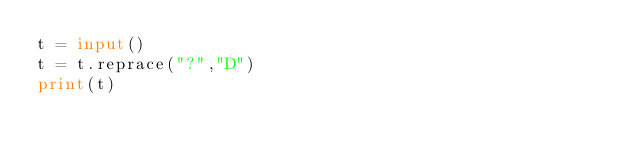Convert code to text. <code><loc_0><loc_0><loc_500><loc_500><_Python_>t = input()
t = t.reprace("?","D")
print(t)</code> 